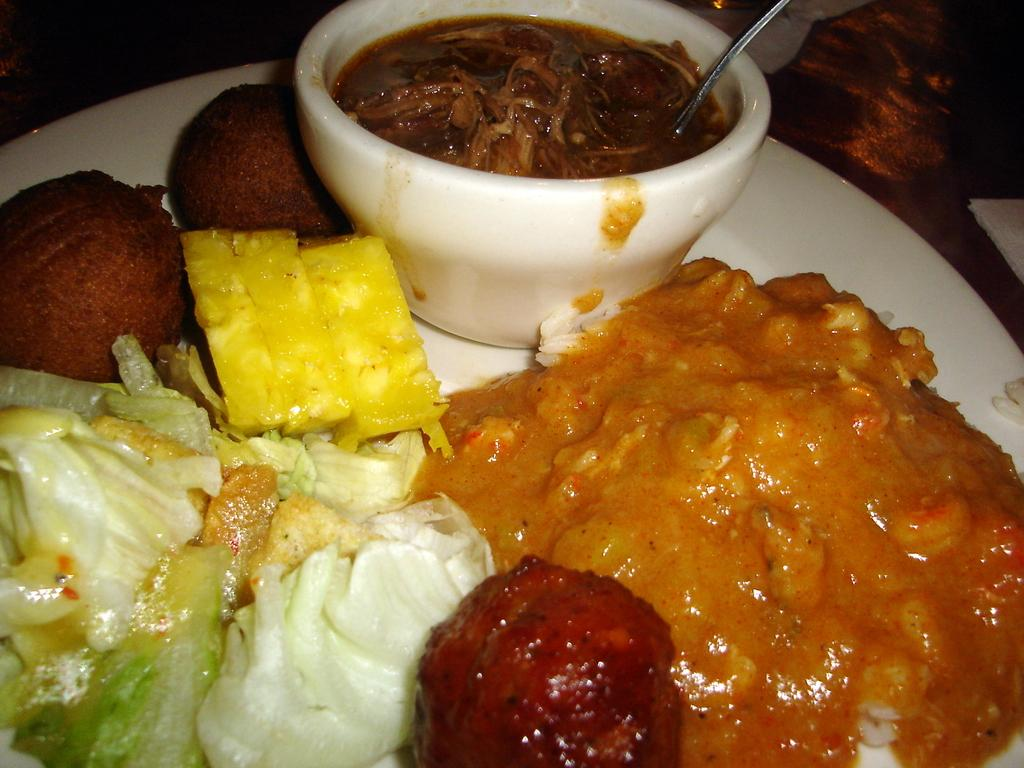What is on the plate in the image? There is food on the plate in the image. What else can be seen on the plate? There is a bowl on the plate. What is inside the bowl? There is soup in the bowl. What utensil is present in the image? There is a spoon in the image. What letters can be seen on the plate? There are no letters visible on the plate in the image. 